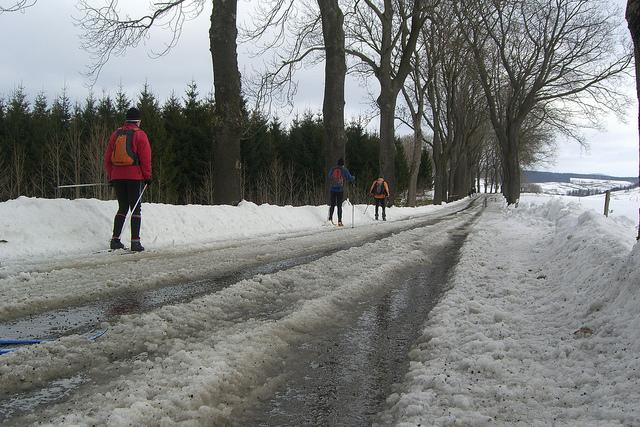What kind of skiing is this?
Write a very short answer. Cross country. How many poles can be seen?
Concise answer only. 4. Has the road been plowed?
Be succinct. Yes. Has the street been cleared?
Be succinct. No. 